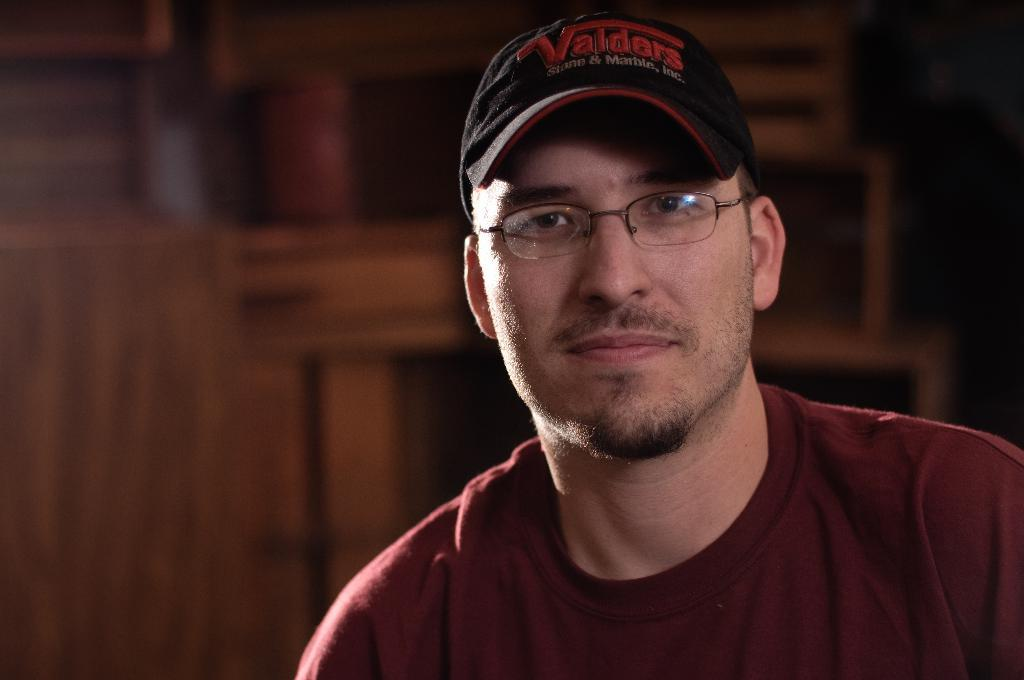Who or what is the main subject in the image? There is a person in the image. Can you describe the person's attire? The person is wearing a cap and spectacles. What can be seen behind the person in the image? There are wooden objects behind the person. What type of wind can be seen blowing through the person's hair in the image? There is no wind present in the image, and the person's hair is not visible. 